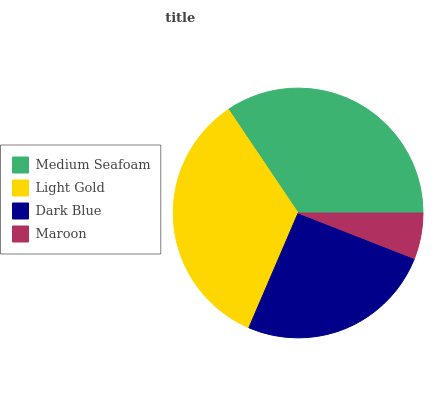Is Maroon the minimum?
Answer yes or no. Yes. Is Medium Seafoam the maximum?
Answer yes or no. Yes. Is Light Gold the minimum?
Answer yes or no. No. Is Light Gold the maximum?
Answer yes or no. No. Is Medium Seafoam greater than Light Gold?
Answer yes or no. Yes. Is Light Gold less than Medium Seafoam?
Answer yes or no. Yes. Is Light Gold greater than Medium Seafoam?
Answer yes or no. No. Is Medium Seafoam less than Light Gold?
Answer yes or no. No. Is Light Gold the high median?
Answer yes or no. Yes. Is Dark Blue the low median?
Answer yes or no. Yes. Is Maroon the high median?
Answer yes or no. No. Is Maroon the low median?
Answer yes or no. No. 